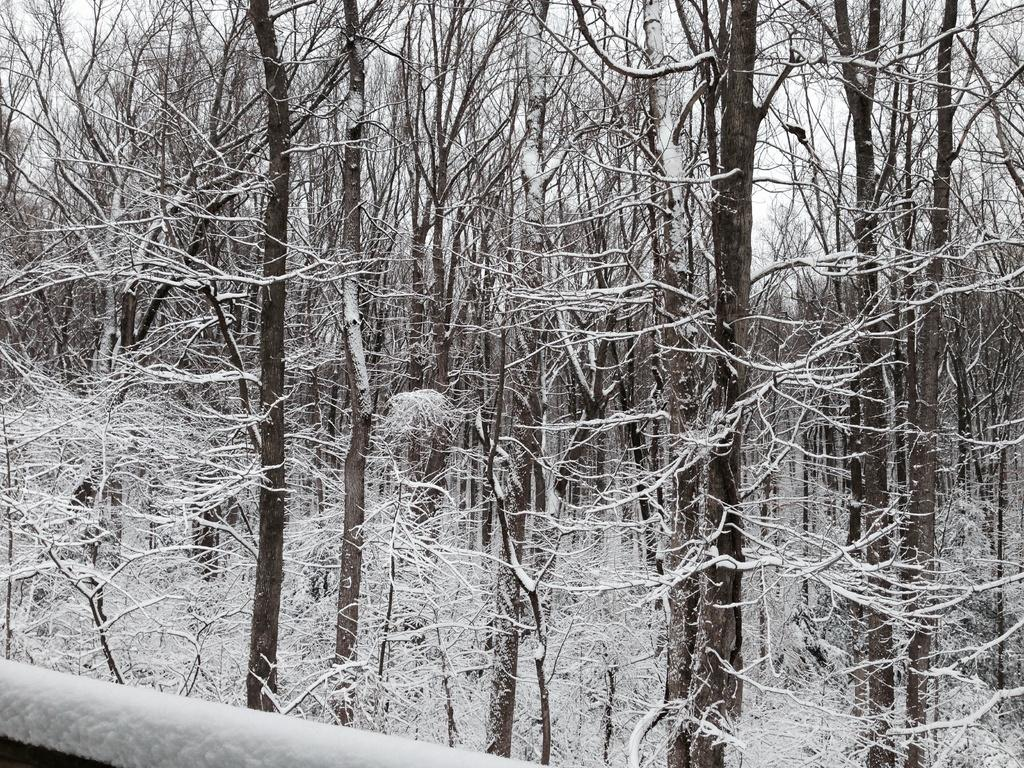What can be seen in the image that might be used for support or safety? There is a railing in the image that could be used for support or safety. What type of natural vegetation is present in the image? There are trees in the image. How is the appearance of the trees affected by the weather or season? The trees are covered by snow, indicating that it is likely cold or wintery. How many eggs are visible in the image? There are no eggs present in the image. What is the value of the dime on the railing in the image? There is no dime present in the image. 